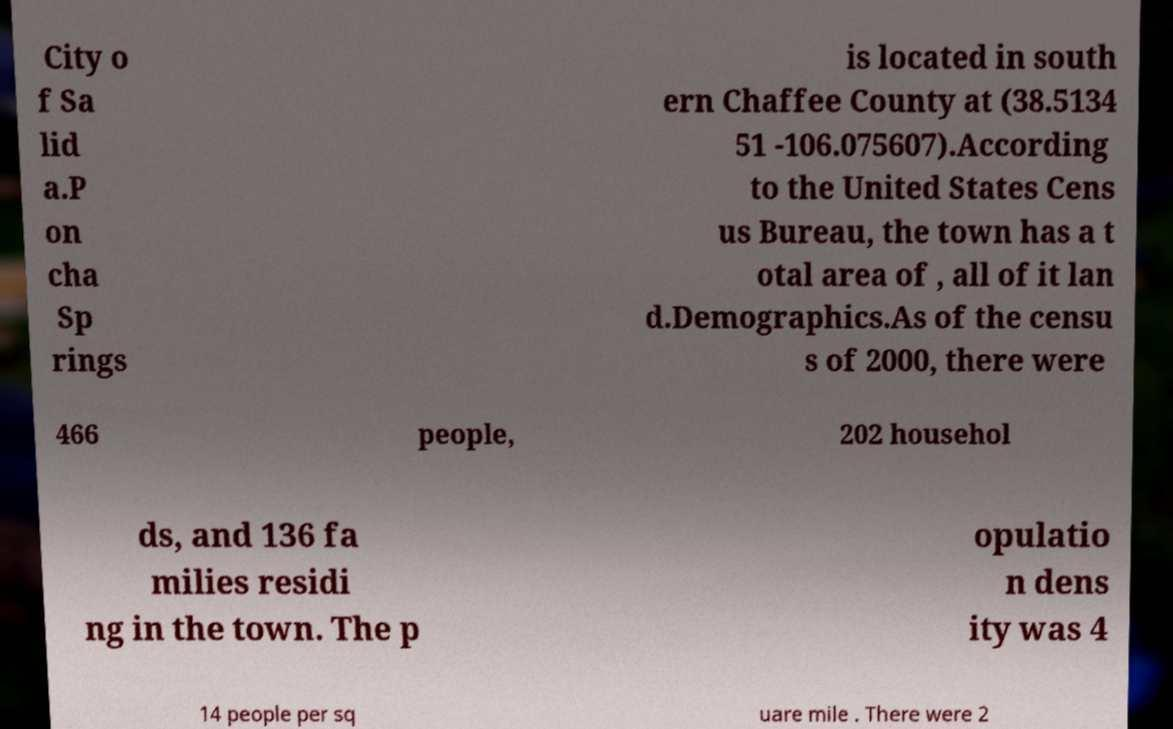Can you accurately transcribe the text from the provided image for me? City o f Sa lid a.P on cha Sp rings is located in south ern Chaffee County at (38.5134 51 -106.075607).According to the United States Cens us Bureau, the town has a t otal area of , all of it lan d.Demographics.As of the censu s of 2000, there were 466 people, 202 househol ds, and 136 fa milies residi ng in the town. The p opulatio n dens ity was 4 14 people per sq uare mile . There were 2 